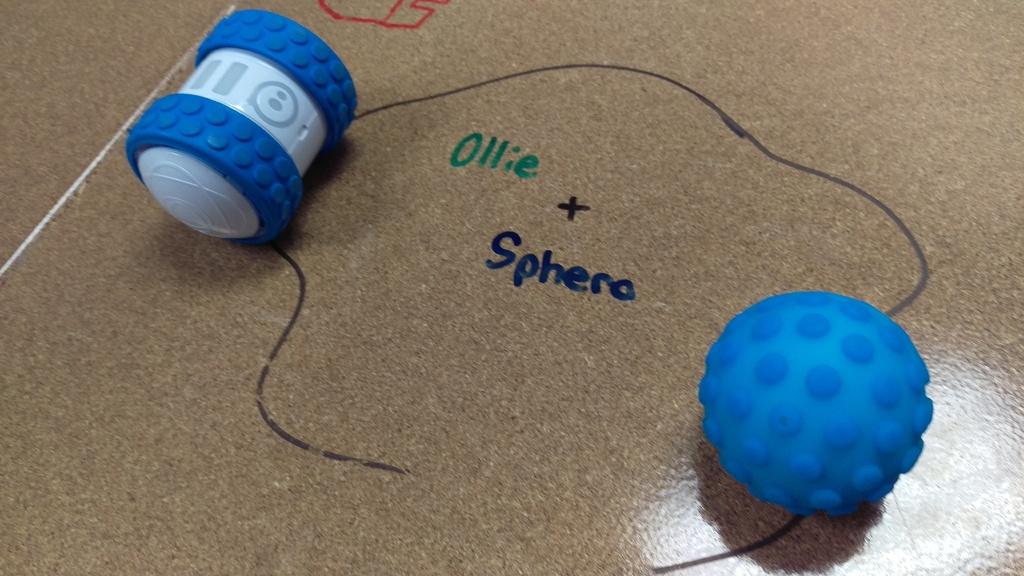What name is written in green?
Offer a terse response. Ollie. What is the text in blue?
Keep it short and to the point. Sphera. 